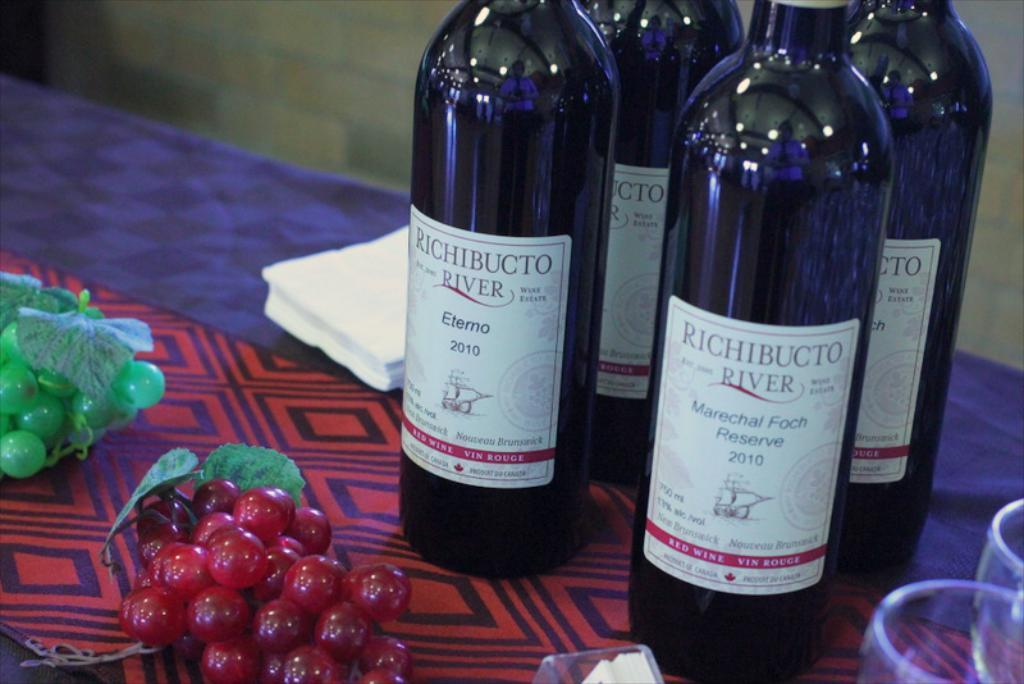<image>
Give a short and clear explanation of the subsequent image. Bottles of Richibucto River wine sit on a table with some fake grapes. 